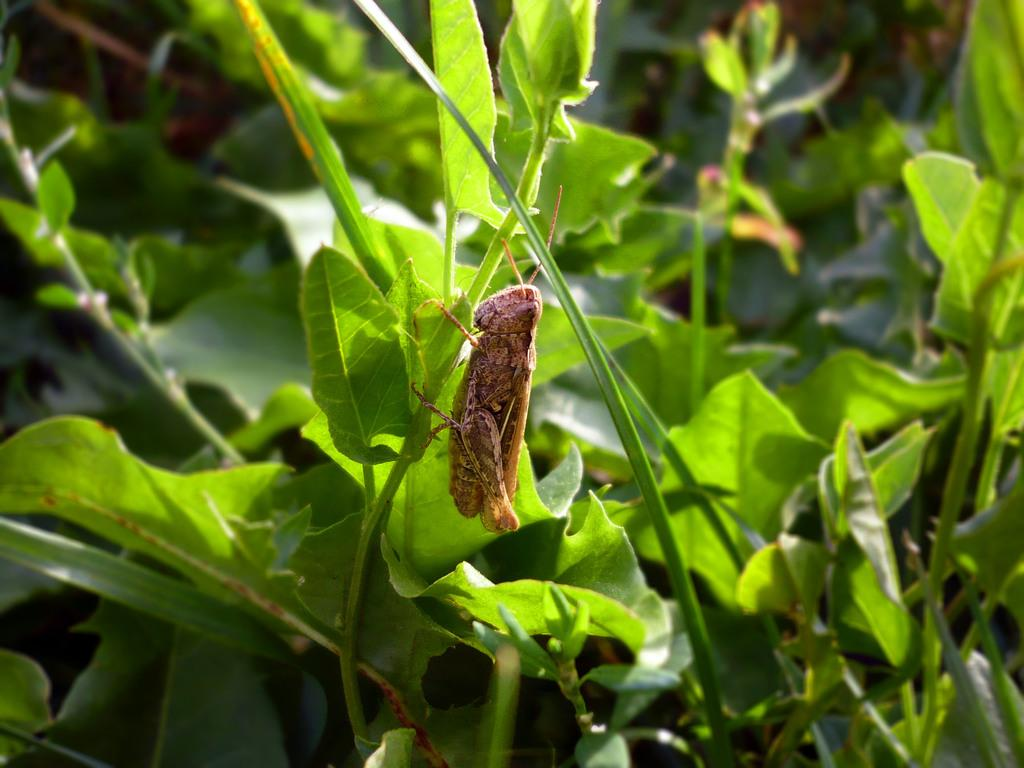What type of creature is present in the image? There is an insect in the image. What is the color of the insect? The insect is brown in color. What else can be seen in the image besides the insect? There is a plant in the image. What is the color of the plant? The plant is green in color. Are there any other plants in the image? Yes, there are other plants in the image. What is the color of the other plants? The other plants are green in color. What type of toys can be seen in the image? There are no toys present in the image. What type of bird is sitting on the plant in the image? There is no bird present in the image; it only features an insect and plants. 